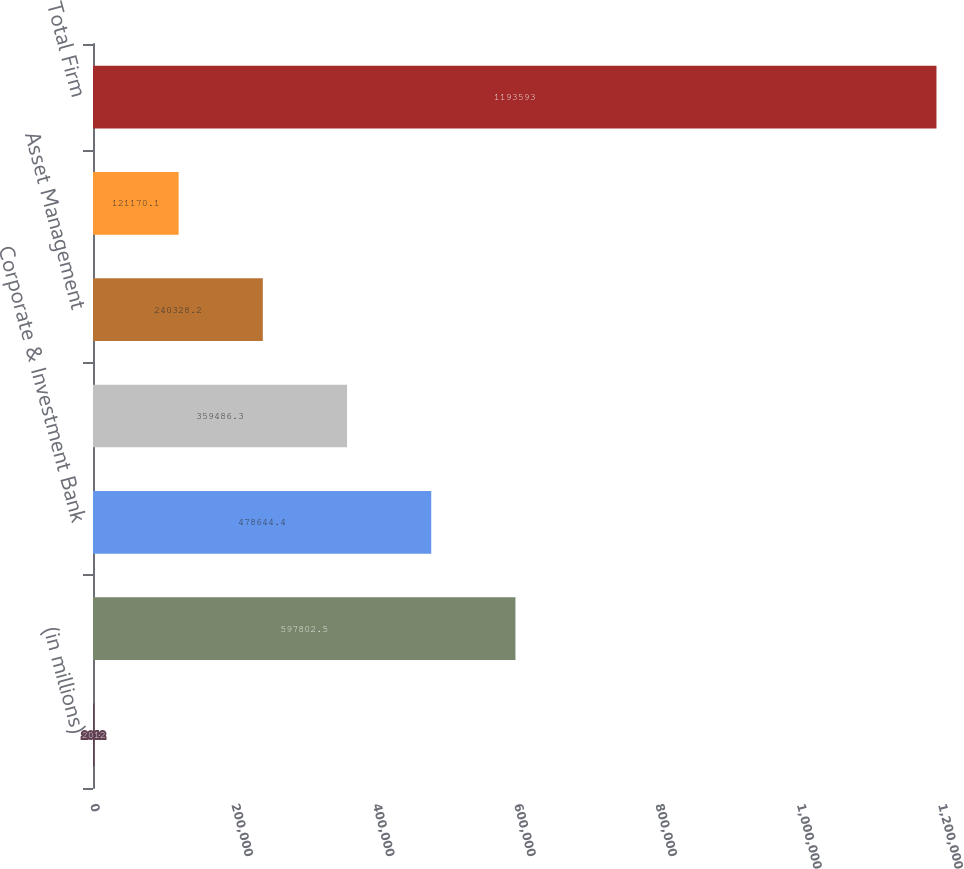Convert chart. <chart><loc_0><loc_0><loc_500><loc_500><bar_chart><fcel>(in millions)<fcel>Consumer & Community Banking<fcel>Corporate & Investment Bank<fcel>Commercial Banking<fcel>Asset Management<fcel>Corporate/Private Equity<fcel>Total Firm<nl><fcel>2012<fcel>597802<fcel>478644<fcel>359486<fcel>240328<fcel>121170<fcel>1.19359e+06<nl></chart> 